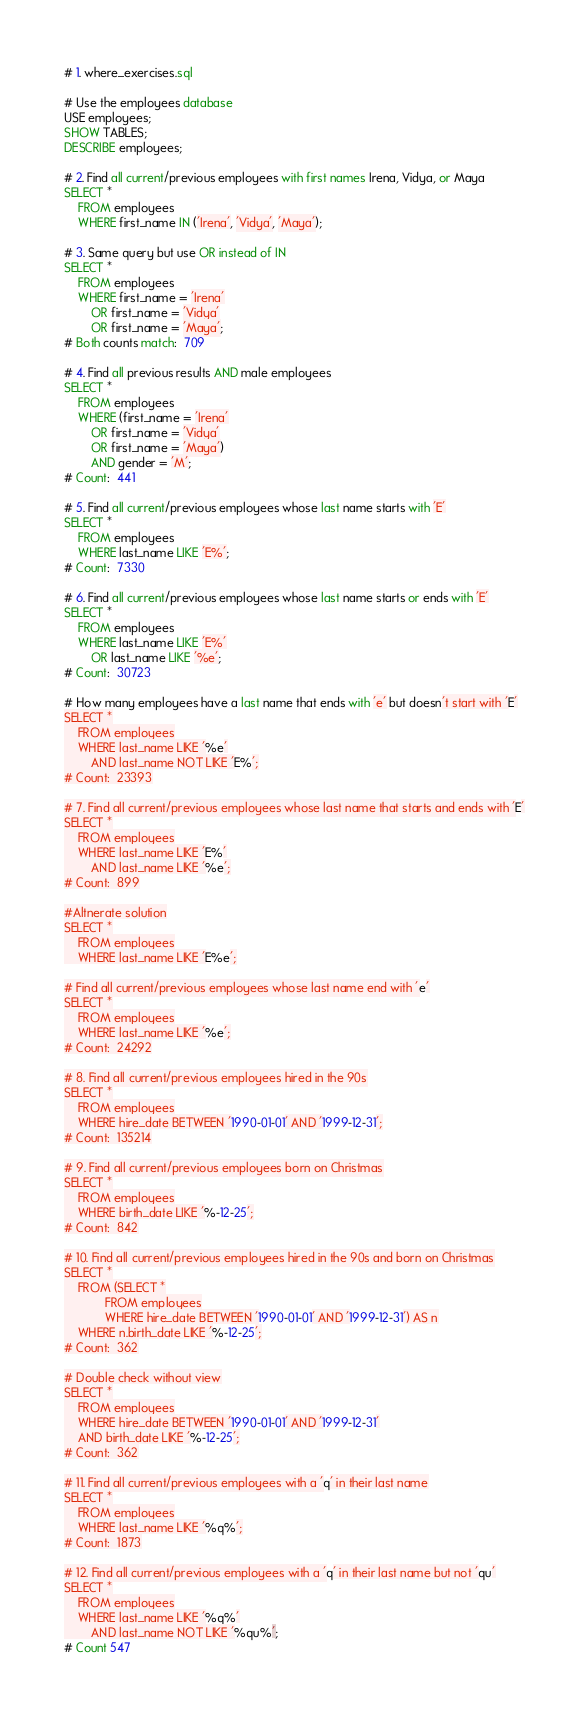Convert code to text. <code><loc_0><loc_0><loc_500><loc_500><_SQL_># 1. where_exercises.sql

# Use the employees database
USE employees;
SHOW TABLES;
DESCRIBE employees;

# 2. Find all current/previous employees with first names Irena, Vidya, or Maya
SELECT *
	FROM employees
	WHERE first_name IN ('Irena', 'Vidya', 'Maya');

# 3. Same query but use OR instead of IN
SELECT *
	FROM employees
	WHERE first_name = 'Irena'
		OR first_name = 'Vidya'
		OR first_name = 'Maya';
# Both counts match:  709

# 4. Find all previous results AND male employees
SELECT *
	FROM employees
	WHERE (first_name = 'Irena'
		OR first_name = 'Vidya'
		OR first_name = 'Maya')
		AND gender = 'M';
# Count:  441

# 5. Find all current/previous employees whose last name starts with 'E'
SELECT *
	FROM employees
	WHERE last_name LIKE 'E%';
# Count:  7330

# 6. Find all current/previous employees whose last name starts or ends with 'E'
SELECT *
	FROM employees
	WHERE last_name LIKE 'E%'
		OR last_name LIKE '%e';
# Count:  30723

# How many employees have a last name that ends with 'e' but doesn't start with 'E'
SELECT *
	FROM employees
	WHERE last_name LIKE '%e'
		AND last_name NOT LIKE 'E%';
# Count:  23393

# 7. Find all current/previous employees whose last name that starts and ends with 'E'
SELECT *
	FROM employees
	WHERE last_name LIKE 'E%'
		AND last_name LIKE '%e';
# Count:  899

#Altnerate solution
SELECT *
	FROM employees
	WHERE last_name LIKE 'E%e';

# Find all current/previous employees whose last name end with 'e'
SELECT *
	FROM employees
	WHERE last_name LIKE '%e';
# Count:  24292

# 8. Find all current/previous employees hired in the 90s
SELECT *
	FROM employees
	WHERE hire_date BETWEEN '1990-01-01' AND '1999-12-31';
# Count:  135214

# 9. Find all current/previous employees born on Christmas
SELECT *
	FROM employees
	WHERE birth_date LIKE '%-12-25';
# Count:  842

# 10. Find all current/previous employees hired in the 90s and born on Christmas
SELECT *
	FROM (SELECT *
			FROM employees
			WHERE hire_date BETWEEN '1990-01-01' AND '1999-12-31') AS n
	WHERE n.birth_date LIKE '%-12-25';
# Count:  362

# Double check without view
SELECT *
	FROM employees
	WHERE hire_date BETWEEN '1990-01-01' AND '1999-12-31'
	AND birth_date LIKE '%-12-25';
# Count:  362

# 11. Find all current/previous employees with a 'q' in their last name
SELECT *
	FROM employees
	WHERE last_name LIKE '%q%';
# Count:  1873

# 12. Find all current/previous employees with a 'q' in their last name but not 'qu'
SELECT *
	FROM employees
	WHERE last_name LIKE '%q%'
		AND last_name NOT LIKE '%qu%';
# Count 547</code> 